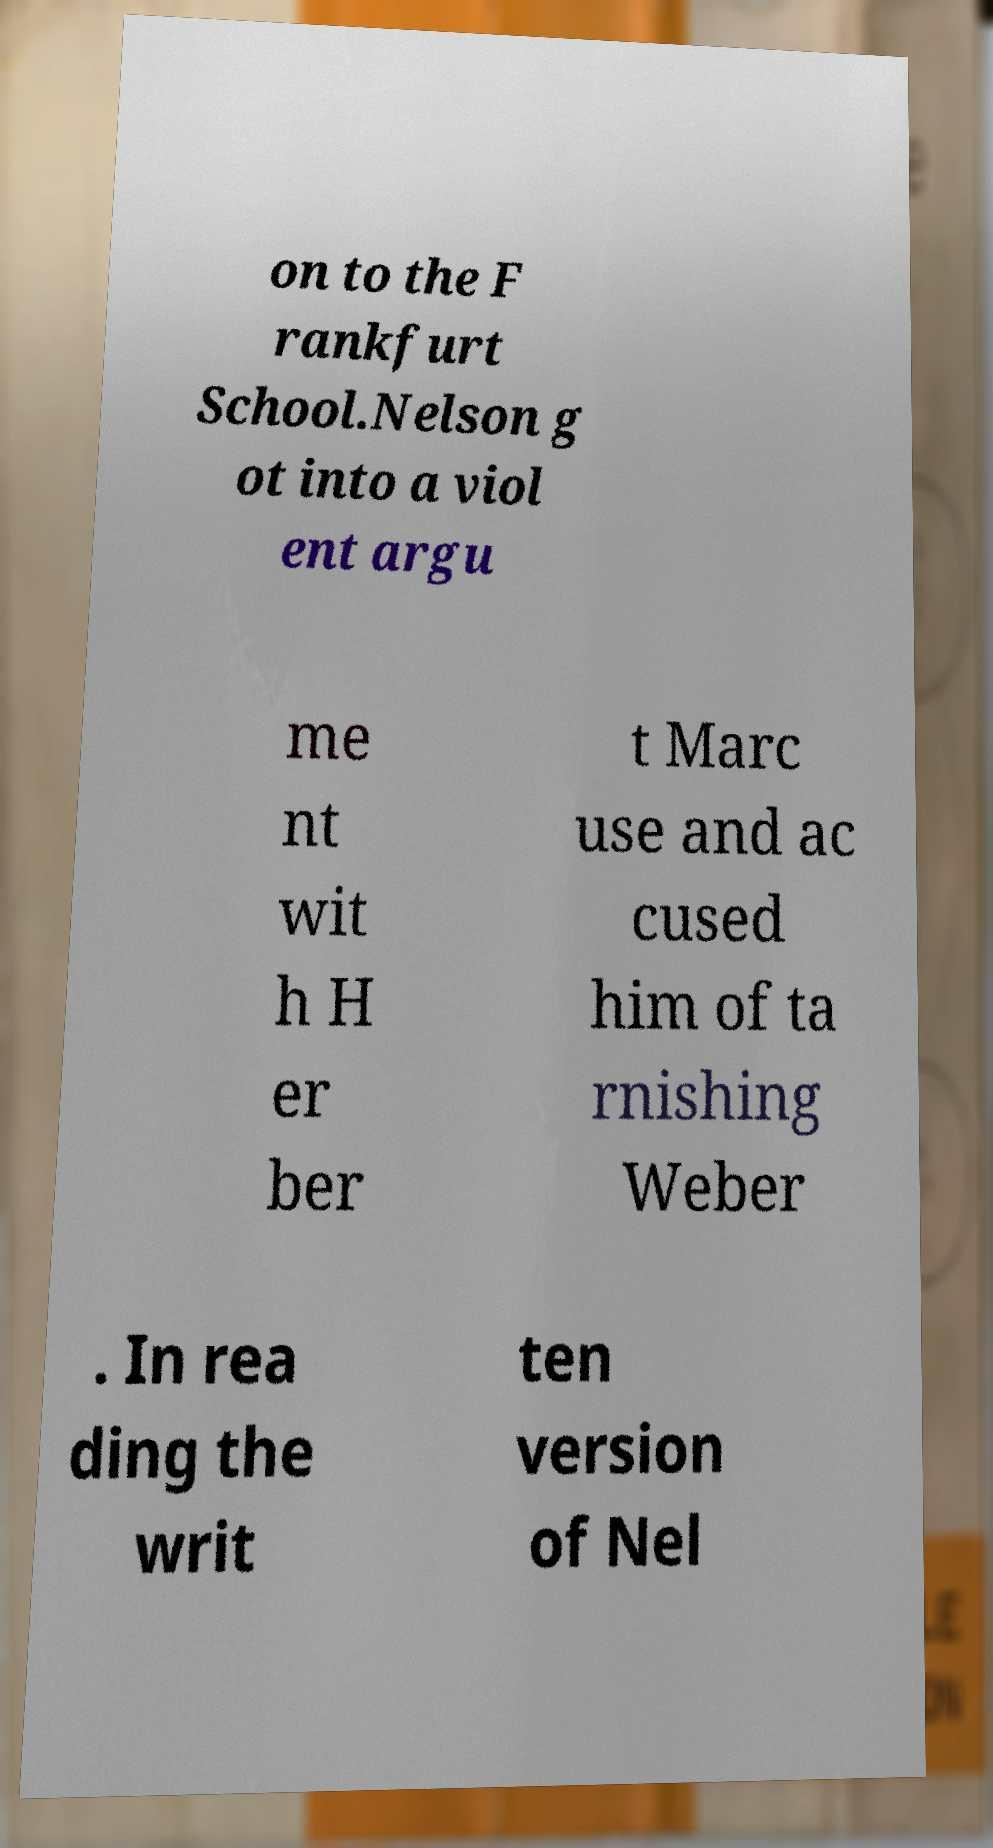I need the written content from this picture converted into text. Can you do that? on to the F rankfurt School.Nelson g ot into a viol ent argu me nt wit h H er ber t Marc use and ac cused him of ta rnishing Weber . In rea ding the writ ten version of Nel 